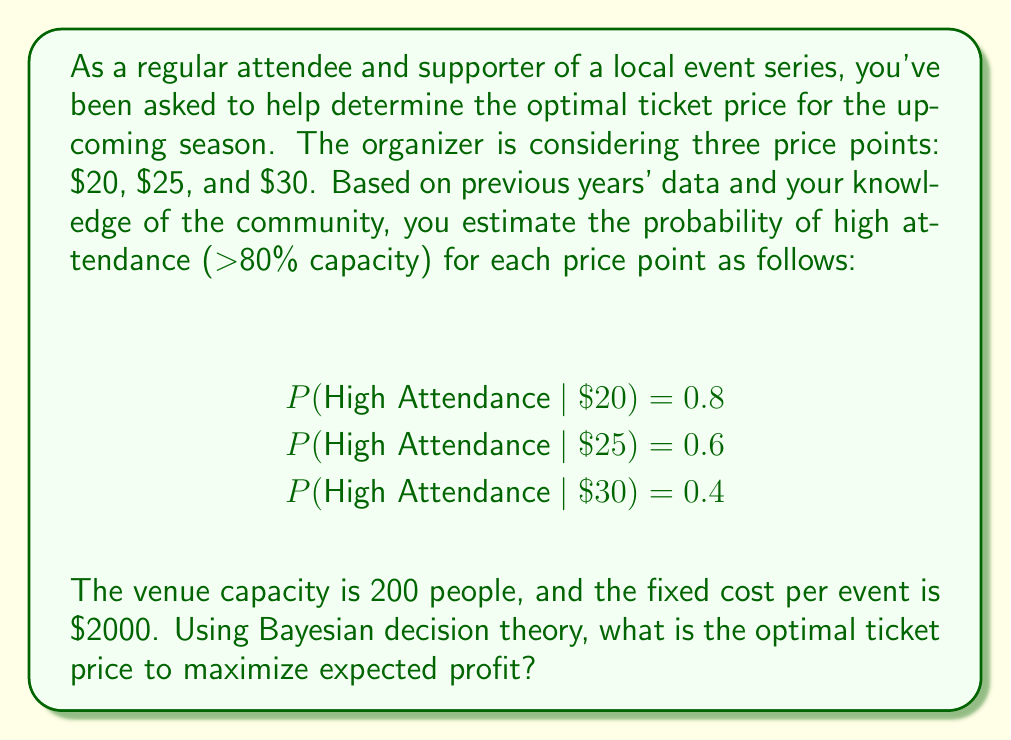Could you help me with this problem? To solve this problem using Bayesian decision theory, we need to calculate the expected profit for each price point and choose the one with the highest expected value. Let's break it down step by step:

1. Calculate the revenue for each scenario:
   - High attendance (80% capacity): 200 * 0.8 = 160 attendees
   - Low attendance (assume 50% capacity): 200 * 0.5 = 100 attendees

2. Calculate the profit for each price point and attendance scenario:
   For $20 ticket:
   - High attendance profit: $(20 * 160) - 2000 = $1200
   - Low attendance profit: $(20 * 100) - 2000 = $0

   For $25 ticket:
   - High attendance profit: $(25 * 160) - 2000 = $2000
   - Low attendance profit: $(25 * 100) - 2000 = $500

   For $30 ticket:
   - High attendance profit: $(30 * 160) - 2000 = $2800
   - Low attendance profit: $(30 * 100) - 2000 = $1000

3. Calculate the expected profit for each price point using the given probabilities:

   For $20 ticket:
   $$E(\text{Profit}_{20}) = 0.8 * 1200 + 0.2 * 0 = 960$$

   For $25 ticket:
   $$E(\text{Profit}_{25}) = 0.6 * 2000 + 0.4 * 500 = 1400$$

   For $30 ticket:
   $$E(\text{Profit}_{30}) = 0.4 * 2800 + 0.6 * 1000 = 1720$$

4. Compare the expected profits:
   $E(\text{Profit}_{20}) = 960$
   $E(\text{Profit}_{25}) = 1400$
   $E(\text{Profit}_{30}) = 1720$

The highest expected profit is achieved with a ticket price of $30.
Answer: The optimal ticket price to maximize expected profit is $30. 